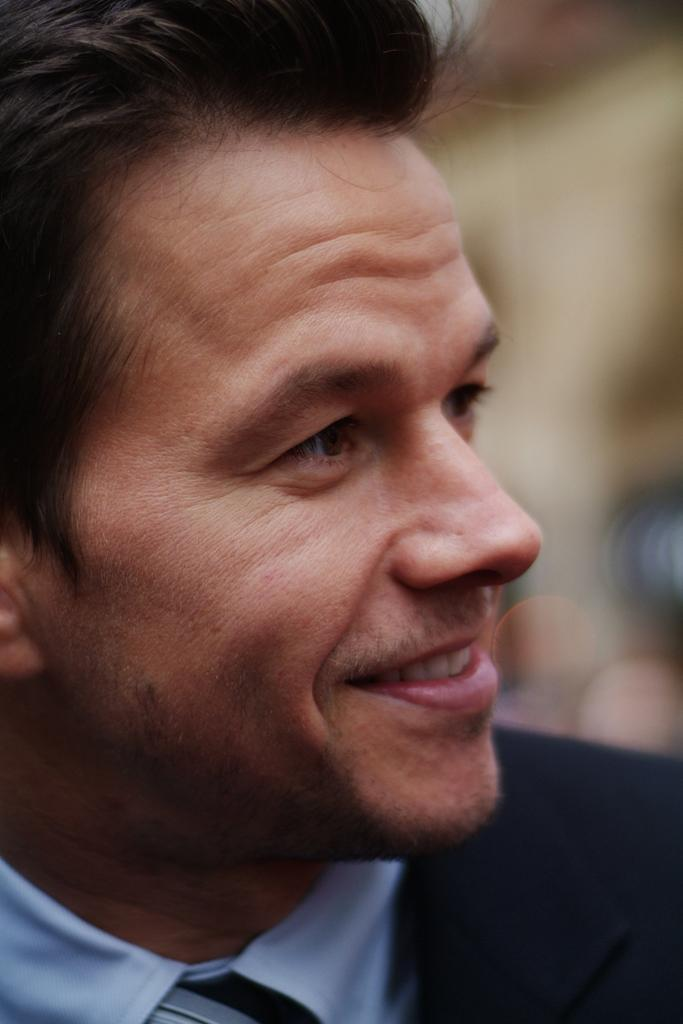What is present in the image? There is a man in the image. How is the man's facial expression in the image? The man is smiling in the image. What type of religious symbol can be seen in the image? There is no religious symbol present in the image; it only features a man who is smiling. How many birds are visible in the image? There are no birds present in the image. 